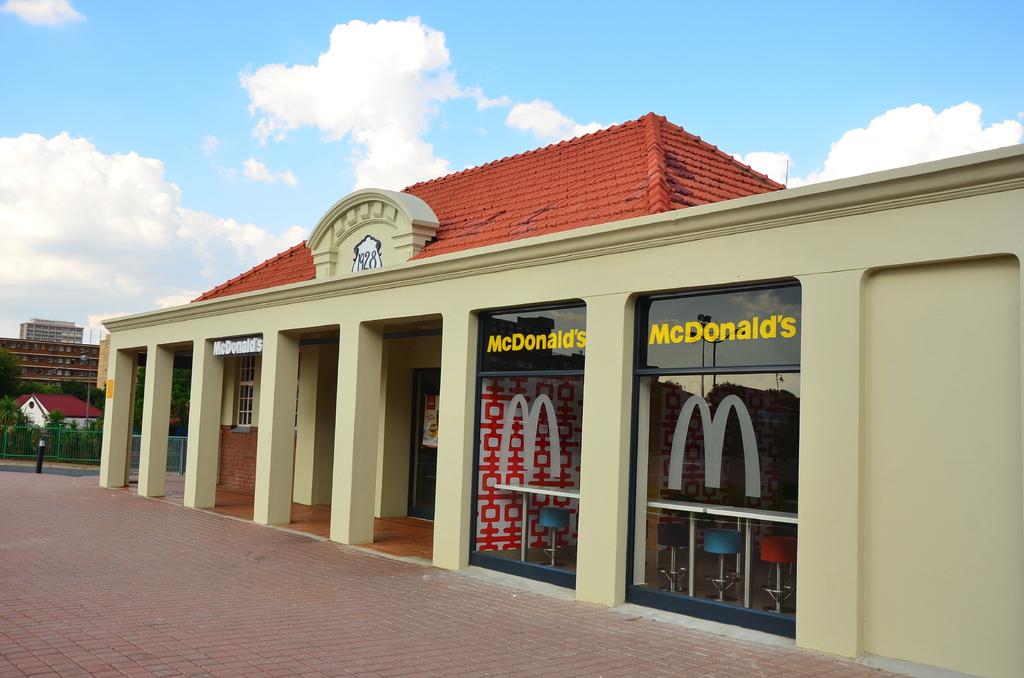What word is on top of the blue patch?
Provide a succinct answer. Unanswerable. What is the name of the restaurant?
Make the answer very short. Mcdonalds. 